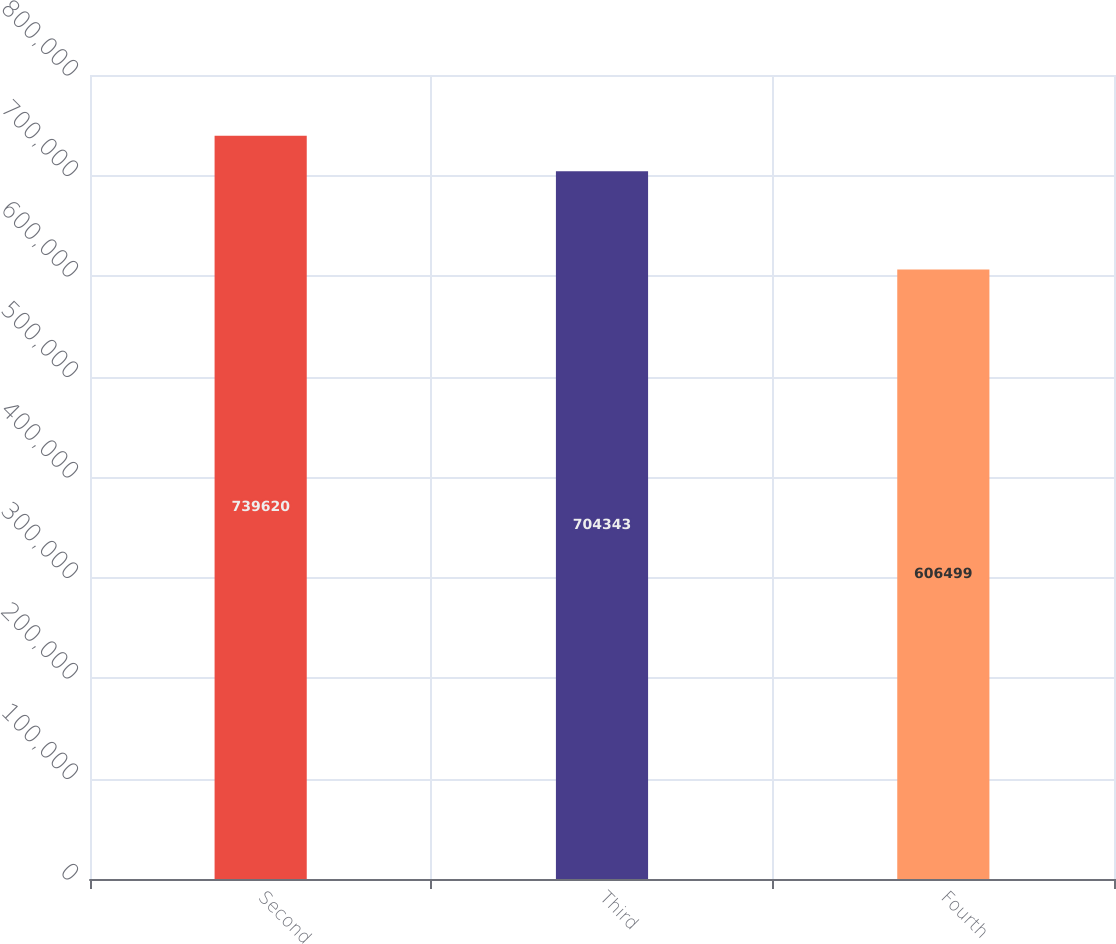<chart> <loc_0><loc_0><loc_500><loc_500><bar_chart><fcel>Second<fcel>Third<fcel>Fourth<nl><fcel>739620<fcel>704343<fcel>606499<nl></chart> 